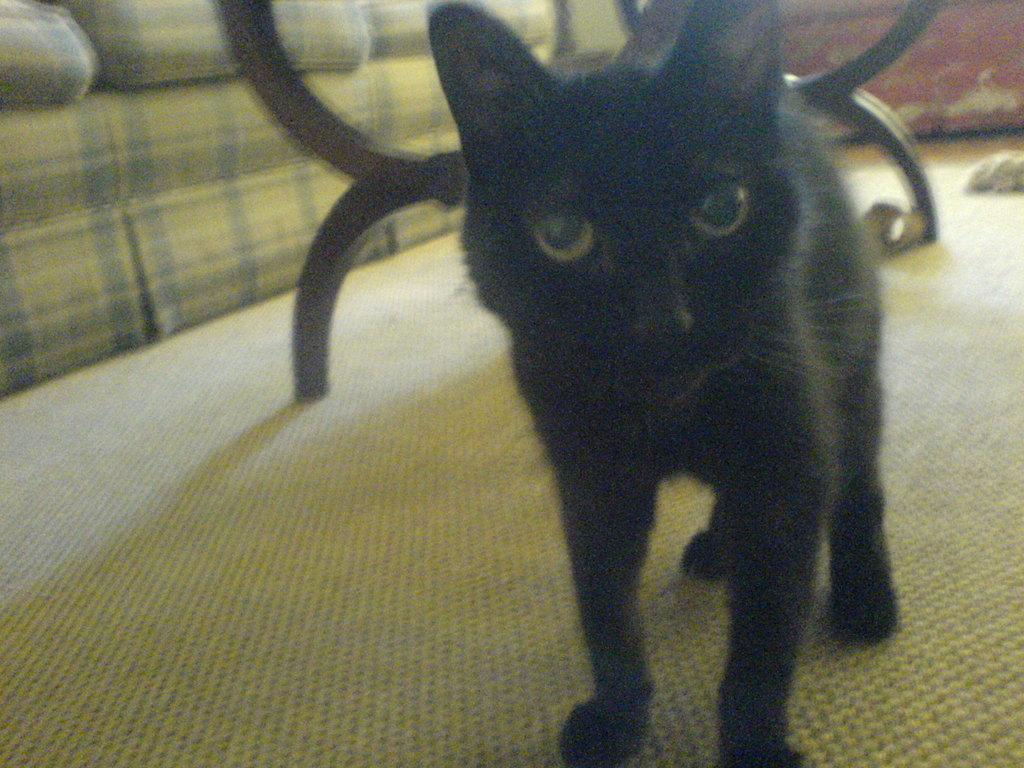What type of animal is in the image? There is a black color cat in the image. What is the cat standing on? The cat is standing on a carpet. What piece of furniture is on the left side of the image? There is a sofa on the left side of the image. What type of magic is the cat performing in the image? There is no magic being performed by the cat in the image; it is simply standing on a carpet. Is there any poison visible in the image? There is no poison present in the image. 